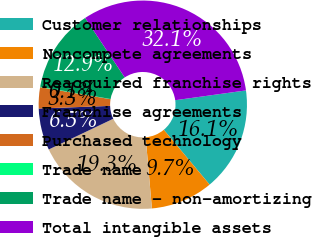<chart> <loc_0><loc_0><loc_500><loc_500><pie_chart><fcel>Customer relationships<fcel>Noncompete agreements<fcel>Reacquired franchise rights<fcel>Franchise agreements<fcel>Purchased technology<fcel>Trade name<fcel>Trade name - non-amortizing<fcel>Total intangible assets<nl><fcel>16.11%<fcel>9.69%<fcel>19.32%<fcel>6.49%<fcel>3.28%<fcel>0.07%<fcel>12.9%<fcel>32.15%<nl></chart> 